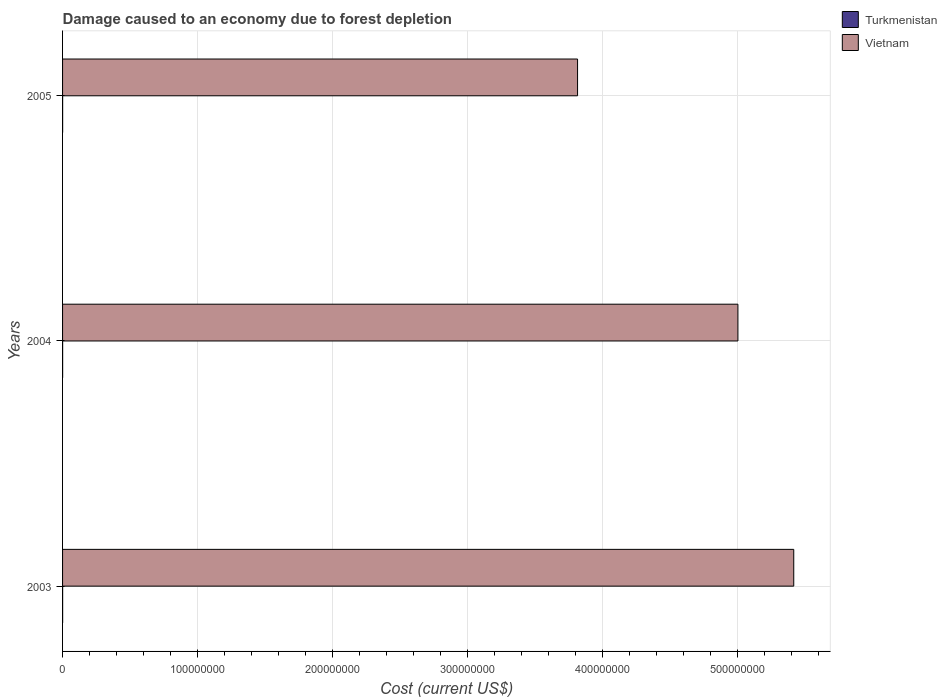How many different coloured bars are there?
Ensure brevity in your answer.  2. Are the number of bars per tick equal to the number of legend labels?
Keep it short and to the point. Yes. What is the cost of damage caused due to forest depletion in Turkmenistan in 2003?
Your answer should be compact. 4.78e+04. Across all years, what is the maximum cost of damage caused due to forest depletion in Turkmenistan?
Ensure brevity in your answer.  4.78e+04. Across all years, what is the minimum cost of damage caused due to forest depletion in Turkmenistan?
Your response must be concise. 4.20e+04. In which year was the cost of damage caused due to forest depletion in Vietnam maximum?
Keep it short and to the point. 2003. What is the total cost of damage caused due to forest depletion in Vietnam in the graph?
Provide a short and direct response. 1.42e+09. What is the difference between the cost of damage caused due to forest depletion in Turkmenistan in 2004 and that in 2005?
Ensure brevity in your answer.  -2466.4. What is the difference between the cost of damage caused due to forest depletion in Vietnam in 2004 and the cost of damage caused due to forest depletion in Turkmenistan in 2005?
Offer a terse response. 5.00e+08. What is the average cost of damage caused due to forest depletion in Turkmenistan per year?
Offer a very short reply. 4.48e+04. In the year 2003, what is the difference between the cost of damage caused due to forest depletion in Vietnam and cost of damage caused due to forest depletion in Turkmenistan?
Offer a terse response. 5.42e+08. In how many years, is the cost of damage caused due to forest depletion in Vietnam greater than 120000000 US$?
Your response must be concise. 3. What is the ratio of the cost of damage caused due to forest depletion in Turkmenistan in 2003 to that in 2005?
Your answer should be very brief. 1.07. What is the difference between the highest and the second highest cost of damage caused due to forest depletion in Turkmenistan?
Your answer should be compact. 3313.84. What is the difference between the highest and the lowest cost of damage caused due to forest depletion in Vietnam?
Keep it short and to the point. 1.60e+08. In how many years, is the cost of damage caused due to forest depletion in Turkmenistan greater than the average cost of damage caused due to forest depletion in Turkmenistan taken over all years?
Your answer should be very brief. 1. What does the 2nd bar from the top in 2004 represents?
Give a very brief answer. Turkmenistan. What does the 1st bar from the bottom in 2004 represents?
Give a very brief answer. Turkmenistan. Are all the bars in the graph horizontal?
Your answer should be very brief. Yes. How many years are there in the graph?
Your answer should be compact. 3. What is the difference between two consecutive major ticks on the X-axis?
Keep it short and to the point. 1.00e+08. Are the values on the major ticks of X-axis written in scientific E-notation?
Ensure brevity in your answer.  No. Does the graph contain any zero values?
Offer a very short reply. No. How are the legend labels stacked?
Provide a succinct answer. Vertical. What is the title of the graph?
Give a very brief answer. Damage caused to an economy due to forest depletion. What is the label or title of the X-axis?
Make the answer very short. Cost (current US$). What is the Cost (current US$) of Turkmenistan in 2003?
Provide a succinct answer. 4.78e+04. What is the Cost (current US$) in Vietnam in 2003?
Offer a terse response. 5.42e+08. What is the Cost (current US$) of Turkmenistan in 2004?
Your answer should be very brief. 4.20e+04. What is the Cost (current US$) of Vietnam in 2004?
Offer a terse response. 5.00e+08. What is the Cost (current US$) in Turkmenistan in 2005?
Make the answer very short. 4.45e+04. What is the Cost (current US$) in Vietnam in 2005?
Give a very brief answer. 3.81e+08. Across all years, what is the maximum Cost (current US$) in Turkmenistan?
Offer a very short reply. 4.78e+04. Across all years, what is the maximum Cost (current US$) of Vietnam?
Offer a terse response. 5.42e+08. Across all years, what is the minimum Cost (current US$) in Turkmenistan?
Ensure brevity in your answer.  4.20e+04. Across all years, what is the minimum Cost (current US$) of Vietnam?
Provide a succinct answer. 3.81e+08. What is the total Cost (current US$) in Turkmenistan in the graph?
Give a very brief answer. 1.34e+05. What is the total Cost (current US$) of Vietnam in the graph?
Keep it short and to the point. 1.42e+09. What is the difference between the Cost (current US$) in Turkmenistan in 2003 and that in 2004?
Ensure brevity in your answer.  5780.24. What is the difference between the Cost (current US$) of Vietnam in 2003 and that in 2004?
Your answer should be compact. 4.14e+07. What is the difference between the Cost (current US$) of Turkmenistan in 2003 and that in 2005?
Your answer should be compact. 3313.84. What is the difference between the Cost (current US$) in Vietnam in 2003 and that in 2005?
Give a very brief answer. 1.60e+08. What is the difference between the Cost (current US$) of Turkmenistan in 2004 and that in 2005?
Provide a short and direct response. -2466.4. What is the difference between the Cost (current US$) of Vietnam in 2004 and that in 2005?
Provide a succinct answer. 1.19e+08. What is the difference between the Cost (current US$) in Turkmenistan in 2003 and the Cost (current US$) in Vietnam in 2004?
Your answer should be compact. -5.00e+08. What is the difference between the Cost (current US$) in Turkmenistan in 2003 and the Cost (current US$) in Vietnam in 2005?
Make the answer very short. -3.81e+08. What is the difference between the Cost (current US$) of Turkmenistan in 2004 and the Cost (current US$) of Vietnam in 2005?
Give a very brief answer. -3.81e+08. What is the average Cost (current US$) in Turkmenistan per year?
Offer a terse response. 4.48e+04. What is the average Cost (current US$) in Vietnam per year?
Make the answer very short. 4.74e+08. In the year 2003, what is the difference between the Cost (current US$) in Turkmenistan and Cost (current US$) in Vietnam?
Your response must be concise. -5.42e+08. In the year 2004, what is the difference between the Cost (current US$) of Turkmenistan and Cost (current US$) of Vietnam?
Your response must be concise. -5.00e+08. In the year 2005, what is the difference between the Cost (current US$) of Turkmenistan and Cost (current US$) of Vietnam?
Your response must be concise. -3.81e+08. What is the ratio of the Cost (current US$) in Turkmenistan in 2003 to that in 2004?
Provide a succinct answer. 1.14. What is the ratio of the Cost (current US$) of Vietnam in 2003 to that in 2004?
Your response must be concise. 1.08. What is the ratio of the Cost (current US$) in Turkmenistan in 2003 to that in 2005?
Your response must be concise. 1.07. What is the ratio of the Cost (current US$) in Vietnam in 2003 to that in 2005?
Ensure brevity in your answer.  1.42. What is the ratio of the Cost (current US$) of Turkmenistan in 2004 to that in 2005?
Your answer should be compact. 0.94. What is the ratio of the Cost (current US$) in Vietnam in 2004 to that in 2005?
Ensure brevity in your answer.  1.31. What is the difference between the highest and the second highest Cost (current US$) of Turkmenistan?
Offer a very short reply. 3313.84. What is the difference between the highest and the second highest Cost (current US$) in Vietnam?
Give a very brief answer. 4.14e+07. What is the difference between the highest and the lowest Cost (current US$) in Turkmenistan?
Keep it short and to the point. 5780.24. What is the difference between the highest and the lowest Cost (current US$) in Vietnam?
Ensure brevity in your answer.  1.60e+08. 